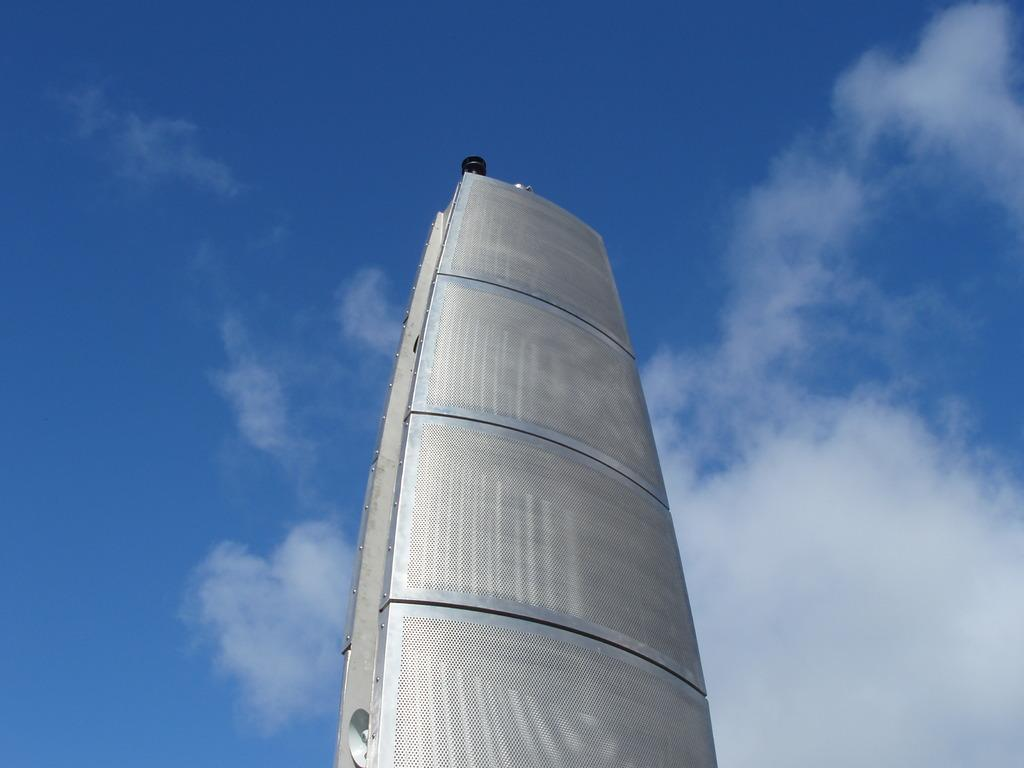What is the main structure in the front of the image? There is a building-like structure in the front of the image. What object can be seen at the bottom of the image? There is a speaker visible at the bottom of the image. What type of natural elements can be seen in the background of the image? There are clouds in the background of the image. What else is visible in the background of the image? The sky is visible in the background of the image. What type of zephyr is blowing through the building in the image? There is no mention of a zephyr or any wind in the image; it only shows a building-like structure, a speaker, and clouds in the background. 